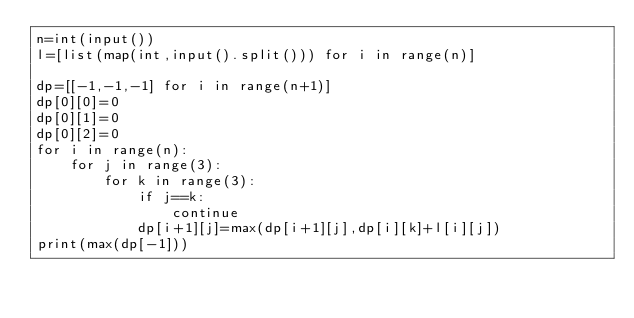<code> <loc_0><loc_0><loc_500><loc_500><_Python_>n=int(input())
l=[list(map(int,input().split())) for i in range(n)]

dp=[[-1,-1,-1] for i in range(n+1)]
dp[0][0]=0
dp[0][1]=0
dp[0][2]=0
for i in range(n):
    for j in range(3):
        for k in range(3):
            if j==k:
                continue
            dp[i+1][j]=max(dp[i+1][j],dp[i][k]+l[i][j])
print(max(dp[-1]))</code> 